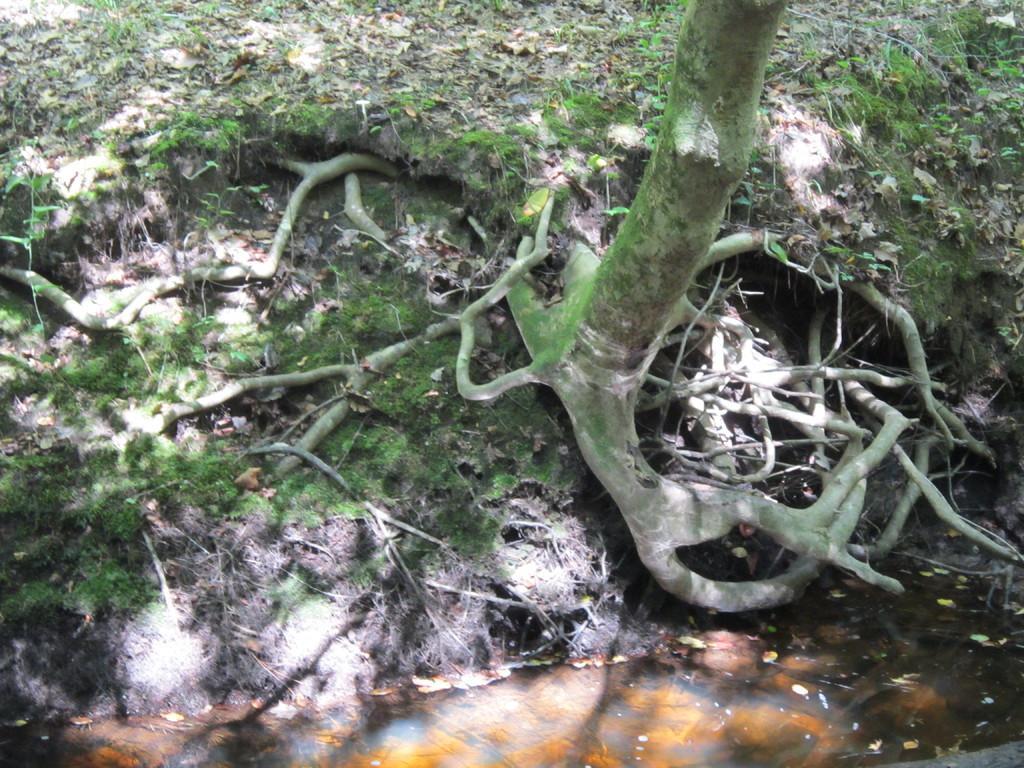Please provide a concise description of this image. In this picture I can see the tree's roots on the ground.. At bottom I can see the water. At the top I can see some leaves and grass. 